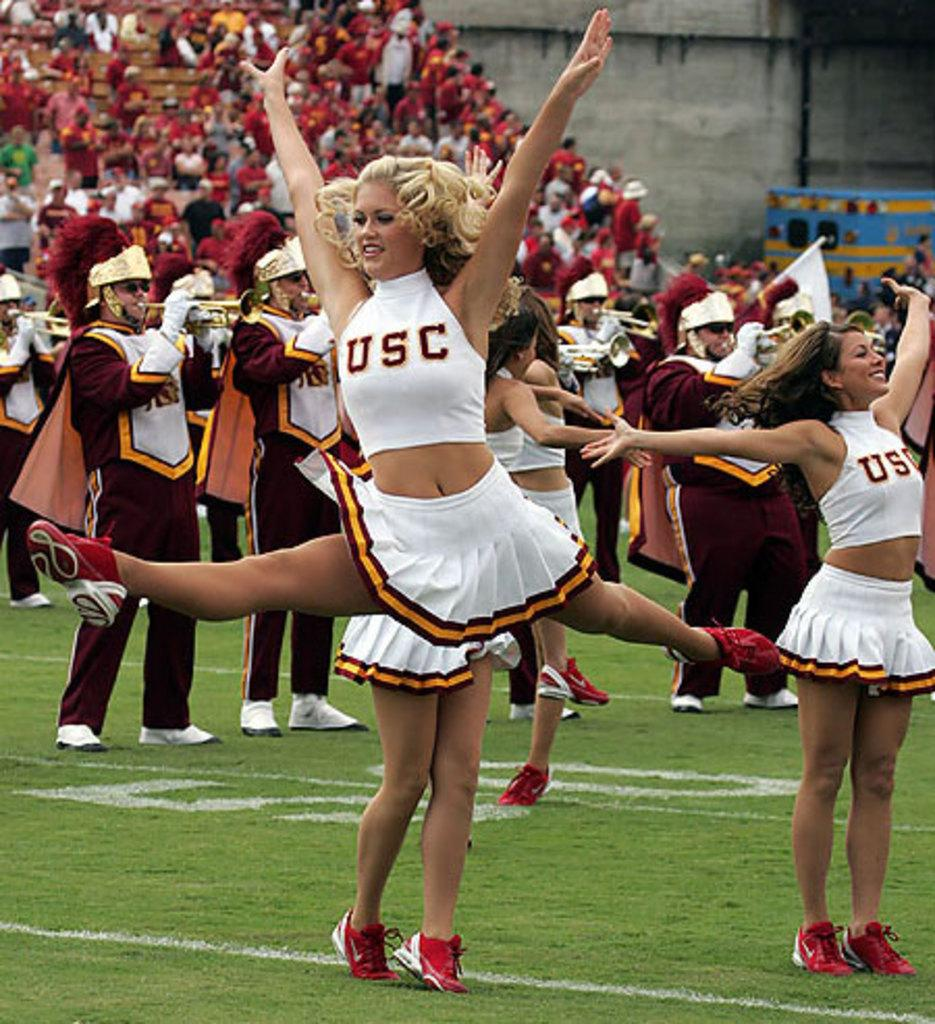<image>
Write a terse but informative summary of the picture. A USC cheerleader executes a spread eagled leap. 